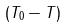<formula> <loc_0><loc_0><loc_500><loc_500>( T _ { 0 } - T )</formula> 